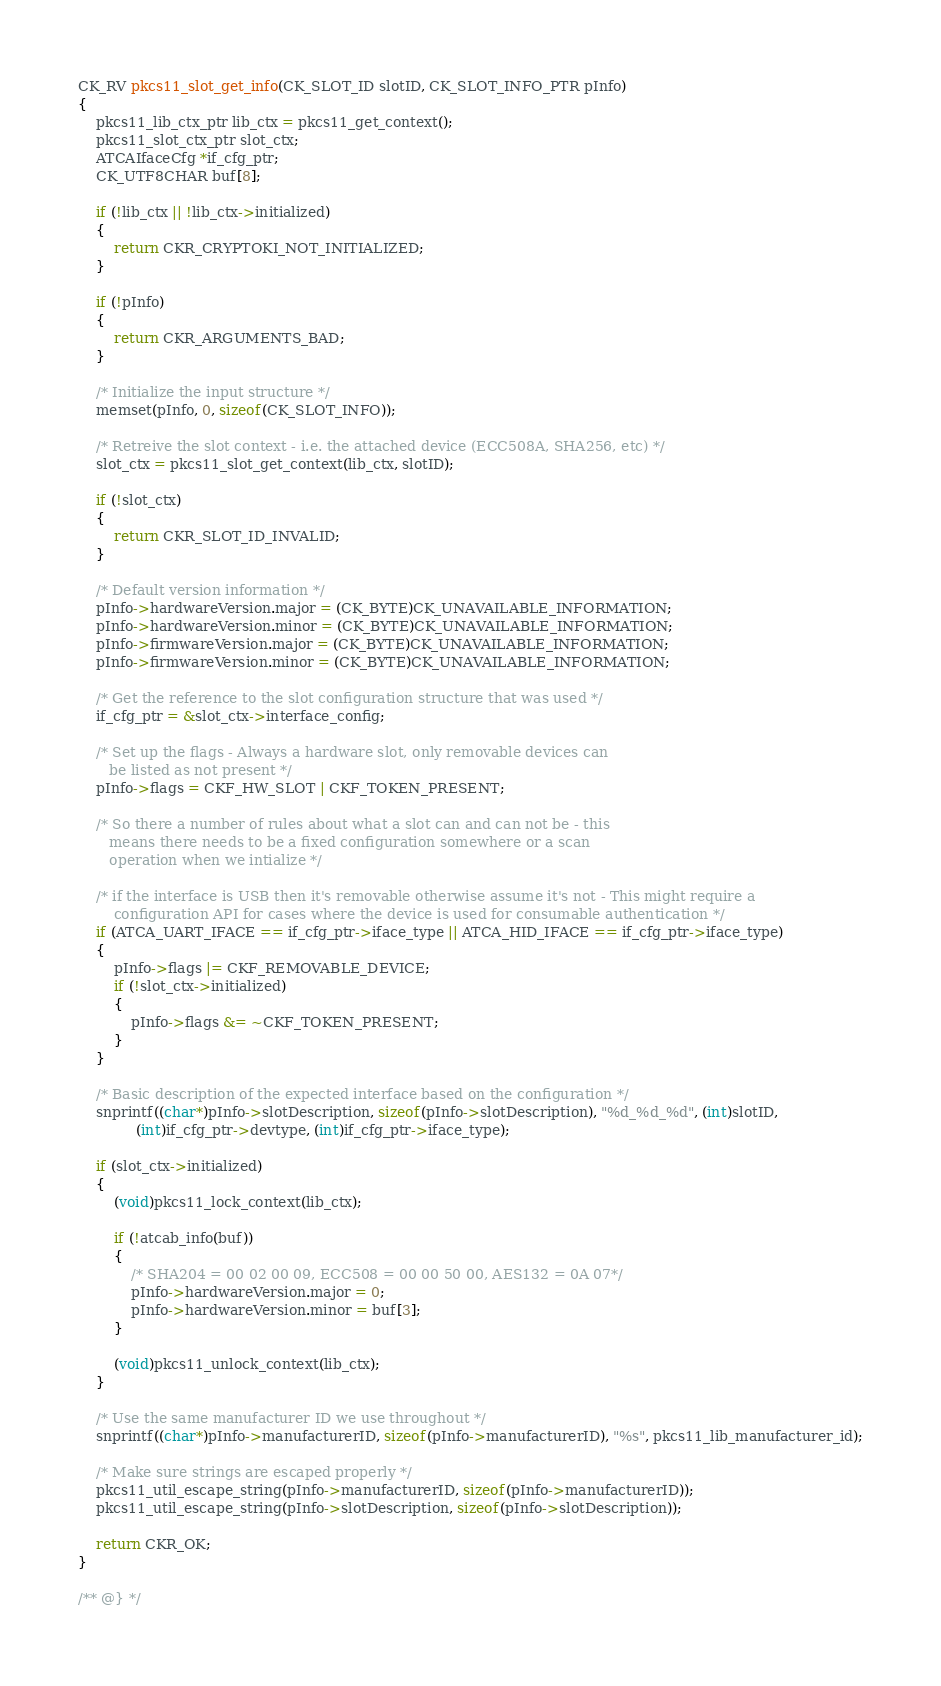Convert code to text. <code><loc_0><loc_0><loc_500><loc_500><_C_>CK_RV pkcs11_slot_get_info(CK_SLOT_ID slotID, CK_SLOT_INFO_PTR pInfo)
{
    pkcs11_lib_ctx_ptr lib_ctx = pkcs11_get_context();
    pkcs11_slot_ctx_ptr slot_ctx;
    ATCAIfaceCfg *if_cfg_ptr;
    CK_UTF8CHAR buf[8];

    if (!lib_ctx || !lib_ctx->initialized)
    {
        return CKR_CRYPTOKI_NOT_INITIALIZED;
    }

    if (!pInfo)
    {
        return CKR_ARGUMENTS_BAD;
    }

    /* Initialize the input structure */
    memset(pInfo, 0, sizeof(CK_SLOT_INFO));

    /* Retreive the slot context - i.e. the attached device (ECC508A, SHA256, etc) */
    slot_ctx = pkcs11_slot_get_context(lib_ctx, slotID);

    if (!slot_ctx)
    {
        return CKR_SLOT_ID_INVALID;
    }

    /* Default version information */
    pInfo->hardwareVersion.major = (CK_BYTE)CK_UNAVAILABLE_INFORMATION;
    pInfo->hardwareVersion.minor = (CK_BYTE)CK_UNAVAILABLE_INFORMATION;
    pInfo->firmwareVersion.major = (CK_BYTE)CK_UNAVAILABLE_INFORMATION;
    pInfo->firmwareVersion.minor = (CK_BYTE)CK_UNAVAILABLE_INFORMATION;

    /* Get the reference to the slot configuration structure that was used */
    if_cfg_ptr = &slot_ctx->interface_config;

    /* Set up the flags - Always a hardware slot, only removable devices can
       be listed as not present */
    pInfo->flags = CKF_HW_SLOT | CKF_TOKEN_PRESENT;

    /* So there a number of rules about what a slot can and can not be - this
       means there needs to be a fixed configuration somewhere or a scan
       operation when we intialize */

    /* if the interface is USB then it's removable otherwise assume it's not - This might require a
        configuration API for cases where the device is used for consumable authentication */
    if (ATCA_UART_IFACE == if_cfg_ptr->iface_type || ATCA_HID_IFACE == if_cfg_ptr->iface_type)
    {
        pInfo->flags |= CKF_REMOVABLE_DEVICE;
        if (!slot_ctx->initialized)
        {
            pInfo->flags &= ~CKF_TOKEN_PRESENT;
        }
    }

    /* Basic description of the expected interface based on the configuration */
    snprintf((char*)pInfo->slotDescription, sizeof(pInfo->slotDescription), "%d_%d_%d", (int)slotID,
             (int)if_cfg_ptr->devtype, (int)if_cfg_ptr->iface_type);

    if (slot_ctx->initialized)
    {
        (void)pkcs11_lock_context(lib_ctx);

        if (!atcab_info(buf))
        {
            /* SHA204 = 00 02 00 09, ECC508 = 00 00 50 00, AES132 = 0A 07*/
            pInfo->hardwareVersion.major = 0;
            pInfo->hardwareVersion.minor = buf[3];
        }

        (void)pkcs11_unlock_context(lib_ctx);
    }

    /* Use the same manufacturer ID we use throughout */
    snprintf((char*)pInfo->manufacturerID, sizeof(pInfo->manufacturerID), "%s", pkcs11_lib_manufacturer_id);

    /* Make sure strings are escaped properly */
    pkcs11_util_escape_string(pInfo->manufacturerID, sizeof(pInfo->manufacturerID));
    pkcs11_util_escape_string(pInfo->slotDescription, sizeof(pInfo->slotDescription));

    return CKR_OK;
}

/** @} */
</code> 